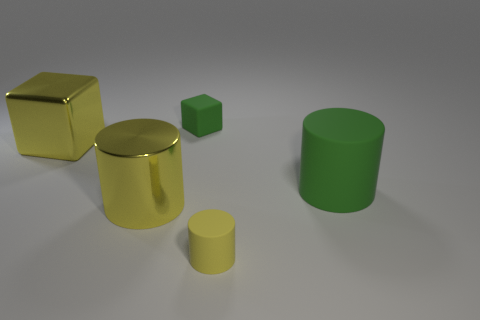There is a block that is the same size as the metal cylinder; what is it made of?
Ensure brevity in your answer.  Metal. There is a big shiny cube; are there any green rubber cylinders left of it?
Provide a short and direct response. No. Are there an equal number of yellow blocks in front of the small yellow object and rubber cylinders?
Provide a succinct answer. No. What is the shape of the green object that is the same size as the yellow rubber thing?
Make the answer very short. Cube. What is the material of the green block?
Offer a terse response. Rubber. The cylinder that is both in front of the big green matte object and on the right side of the tiny block is what color?
Provide a succinct answer. Yellow. Are there the same number of yellow things that are to the right of the tiny matte block and tiny rubber blocks on the left side of the big yellow metal block?
Give a very brief answer. No. The block that is the same material as the green cylinder is what color?
Your response must be concise. Green. Does the small rubber block have the same color as the big metal object that is behind the big green rubber thing?
Ensure brevity in your answer.  No. There is a tiny thing that is on the left side of the rubber cylinder that is in front of the large rubber object; is there a metal cylinder that is on the right side of it?
Your answer should be very brief. No. 